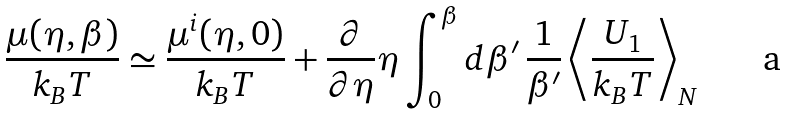Convert formula to latex. <formula><loc_0><loc_0><loc_500><loc_500>\frac { \mu ( \eta , \beta ) } { k _ { B } T } \simeq \frac { \mu ^ { i } ( \eta , 0 ) } { k _ { B } T } + \frac { \partial } { \partial \eta } \eta \int _ { 0 } ^ { \beta } d \beta ^ { \prime } \, \frac { 1 } { \beta ^ { \prime } } \left \langle \frac { U _ { 1 } } { k _ { B } T } \right \rangle _ { N }</formula> 